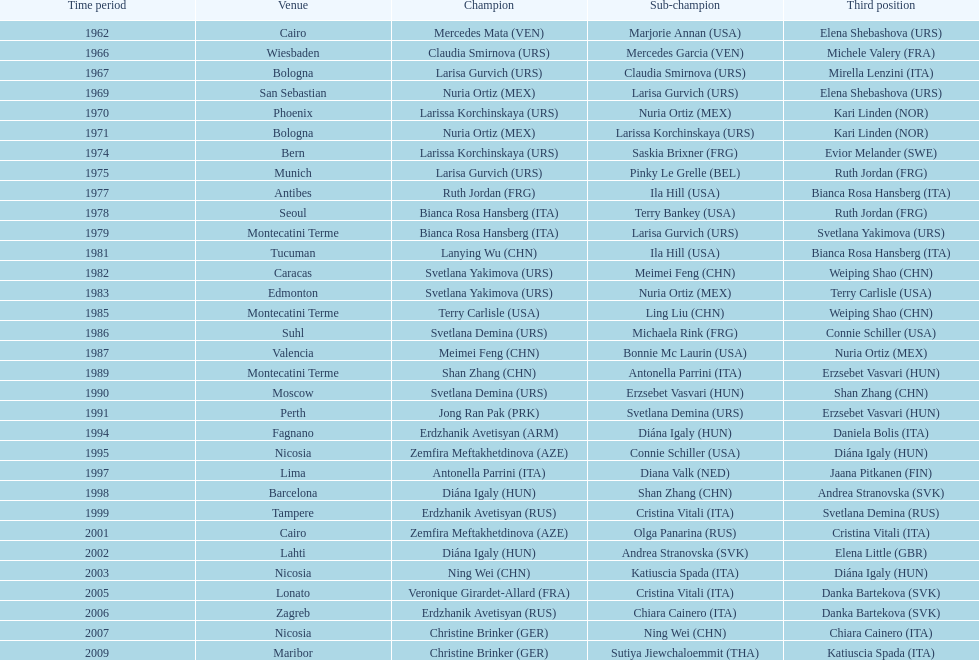What is the total amount of winnings for the united states in gold, silver and bronze? 9. 